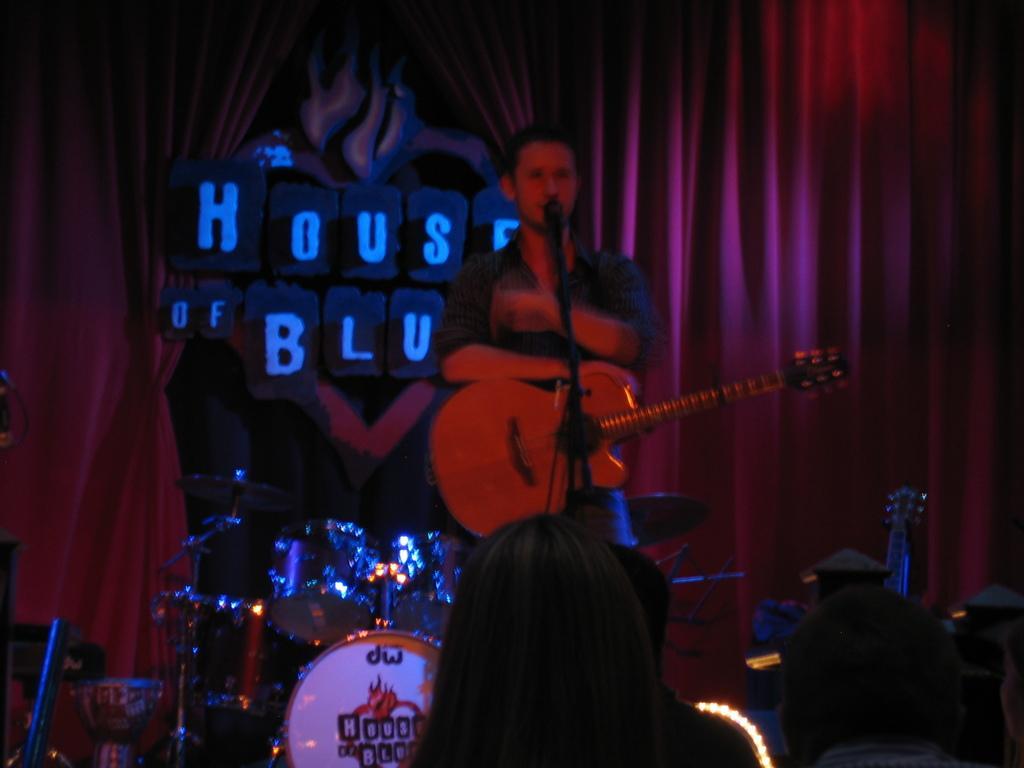How would you summarize this image in a sentence or two? In the picture we can see a man standing and singing the song in the micro phone and holding a guitar which is red in color, in the background we can see a musical instruments like drums and orchestra, and also a red curtain beside it there is a board "HOUSE BLU." 